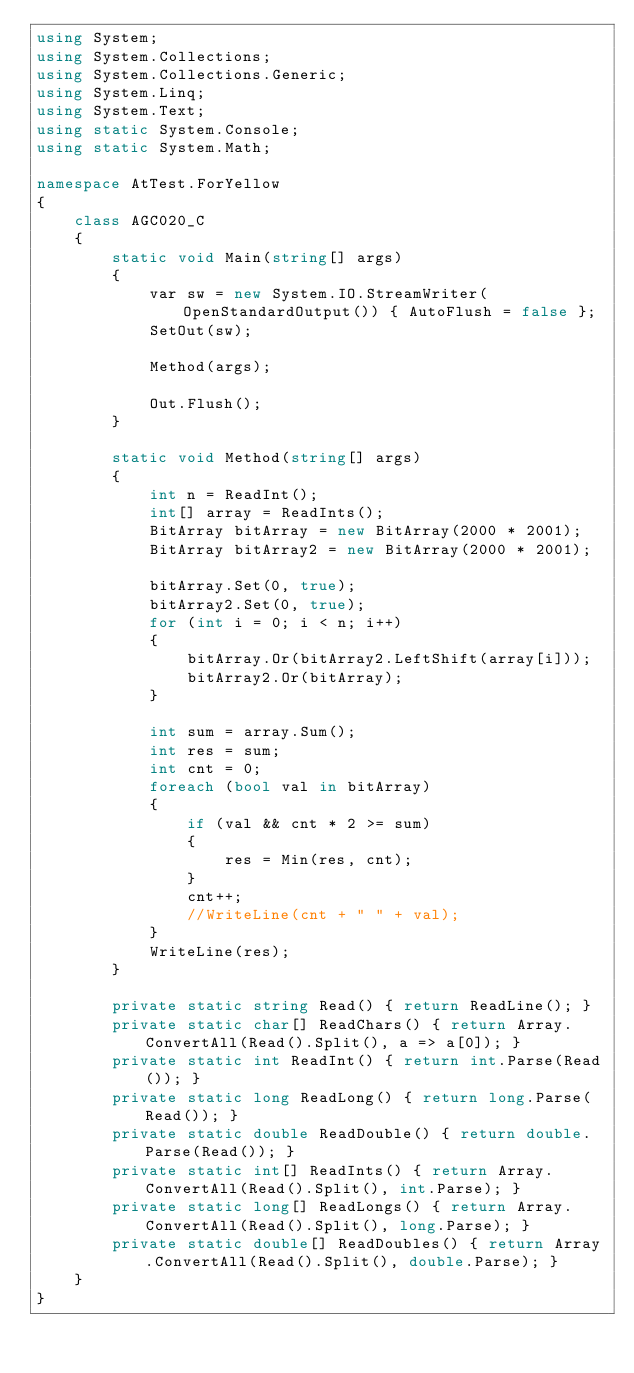<code> <loc_0><loc_0><loc_500><loc_500><_C#_>using System;
using System.Collections;
using System.Collections.Generic;
using System.Linq;
using System.Text;
using static System.Console;
using static System.Math;

namespace AtTest.ForYellow
{
    class AGC020_C
    {
        static void Main(string[] args)
        {
            var sw = new System.IO.StreamWriter(OpenStandardOutput()) { AutoFlush = false };
            SetOut(sw);

            Method(args);

            Out.Flush();
        }

        static void Method(string[] args)
        {
            int n = ReadInt();
            int[] array = ReadInts();
            BitArray bitArray = new BitArray(2000 * 2001);
            BitArray bitArray2 = new BitArray(2000 * 2001);

            bitArray.Set(0, true);
            bitArray2.Set(0, true);
            for (int i = 0; i < n; i++)
            {
                bitArray.Or(bitArray2.LeftShift(array[i]));
                bitArray2.Or(bitArray);
            }

            int sum = array.Sum();
            int res = sum;
            int cnt = 0;
            foreach (bool val in bitArray)
            {
                if (val && cnt * 2 >= sum)
                {
                    res = Min(res, cnt);
                }
                cnt++;
                //WriteLine(cnt + " " + val);
            }
            WriteLine(res);
        }

        private static string Read() { return ReadLine(); }
        private static char[] ReadChars() { return Array.ConvertAll(Read().Split(), a => a[0]); }
        private static int ReadInt() { return int.Parse(Read()); }
        private static long ReadLong() { return long.Parse(Read()); }
        private static double ReadDouble() { return double.Parse(Read()); }
        private static int[] ReadInts() { return Array.ConvertAll(Read().Split(), int.Parse); }
        private static long[] ReadLongs() { return Array.ConvertAll(Read().Split(), long.Parse); }
        private static double[] ReadDoubles() { return Array.ConvertAll(Read().Split(), double.Parse); }
    }
}
</code> 